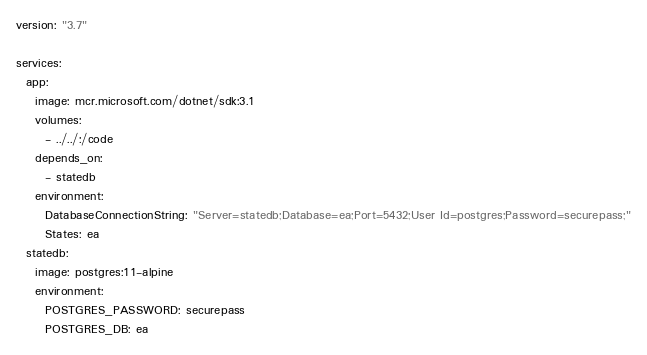<code> <loc_0><loc_0><loc_500><loc_500><_YAML_>version: "3.7"

services:
  app:
    image: mcr.microsoft.com/dotnet/sdk:3.1
    volumes:
      - ../../:/code
    depends_on:
      - statedb
    environment:
      DatabaseConnectionString: "Server=statedb;Database=ea;Port=5432;User Id=postgres;Password=securepass;"
      States: ea
  statedb:
    image: postgres:11-alpine
    environment:
      POSTGRES_PASSWORD: securepass
      POSTGRES_DB: ea
</code> 